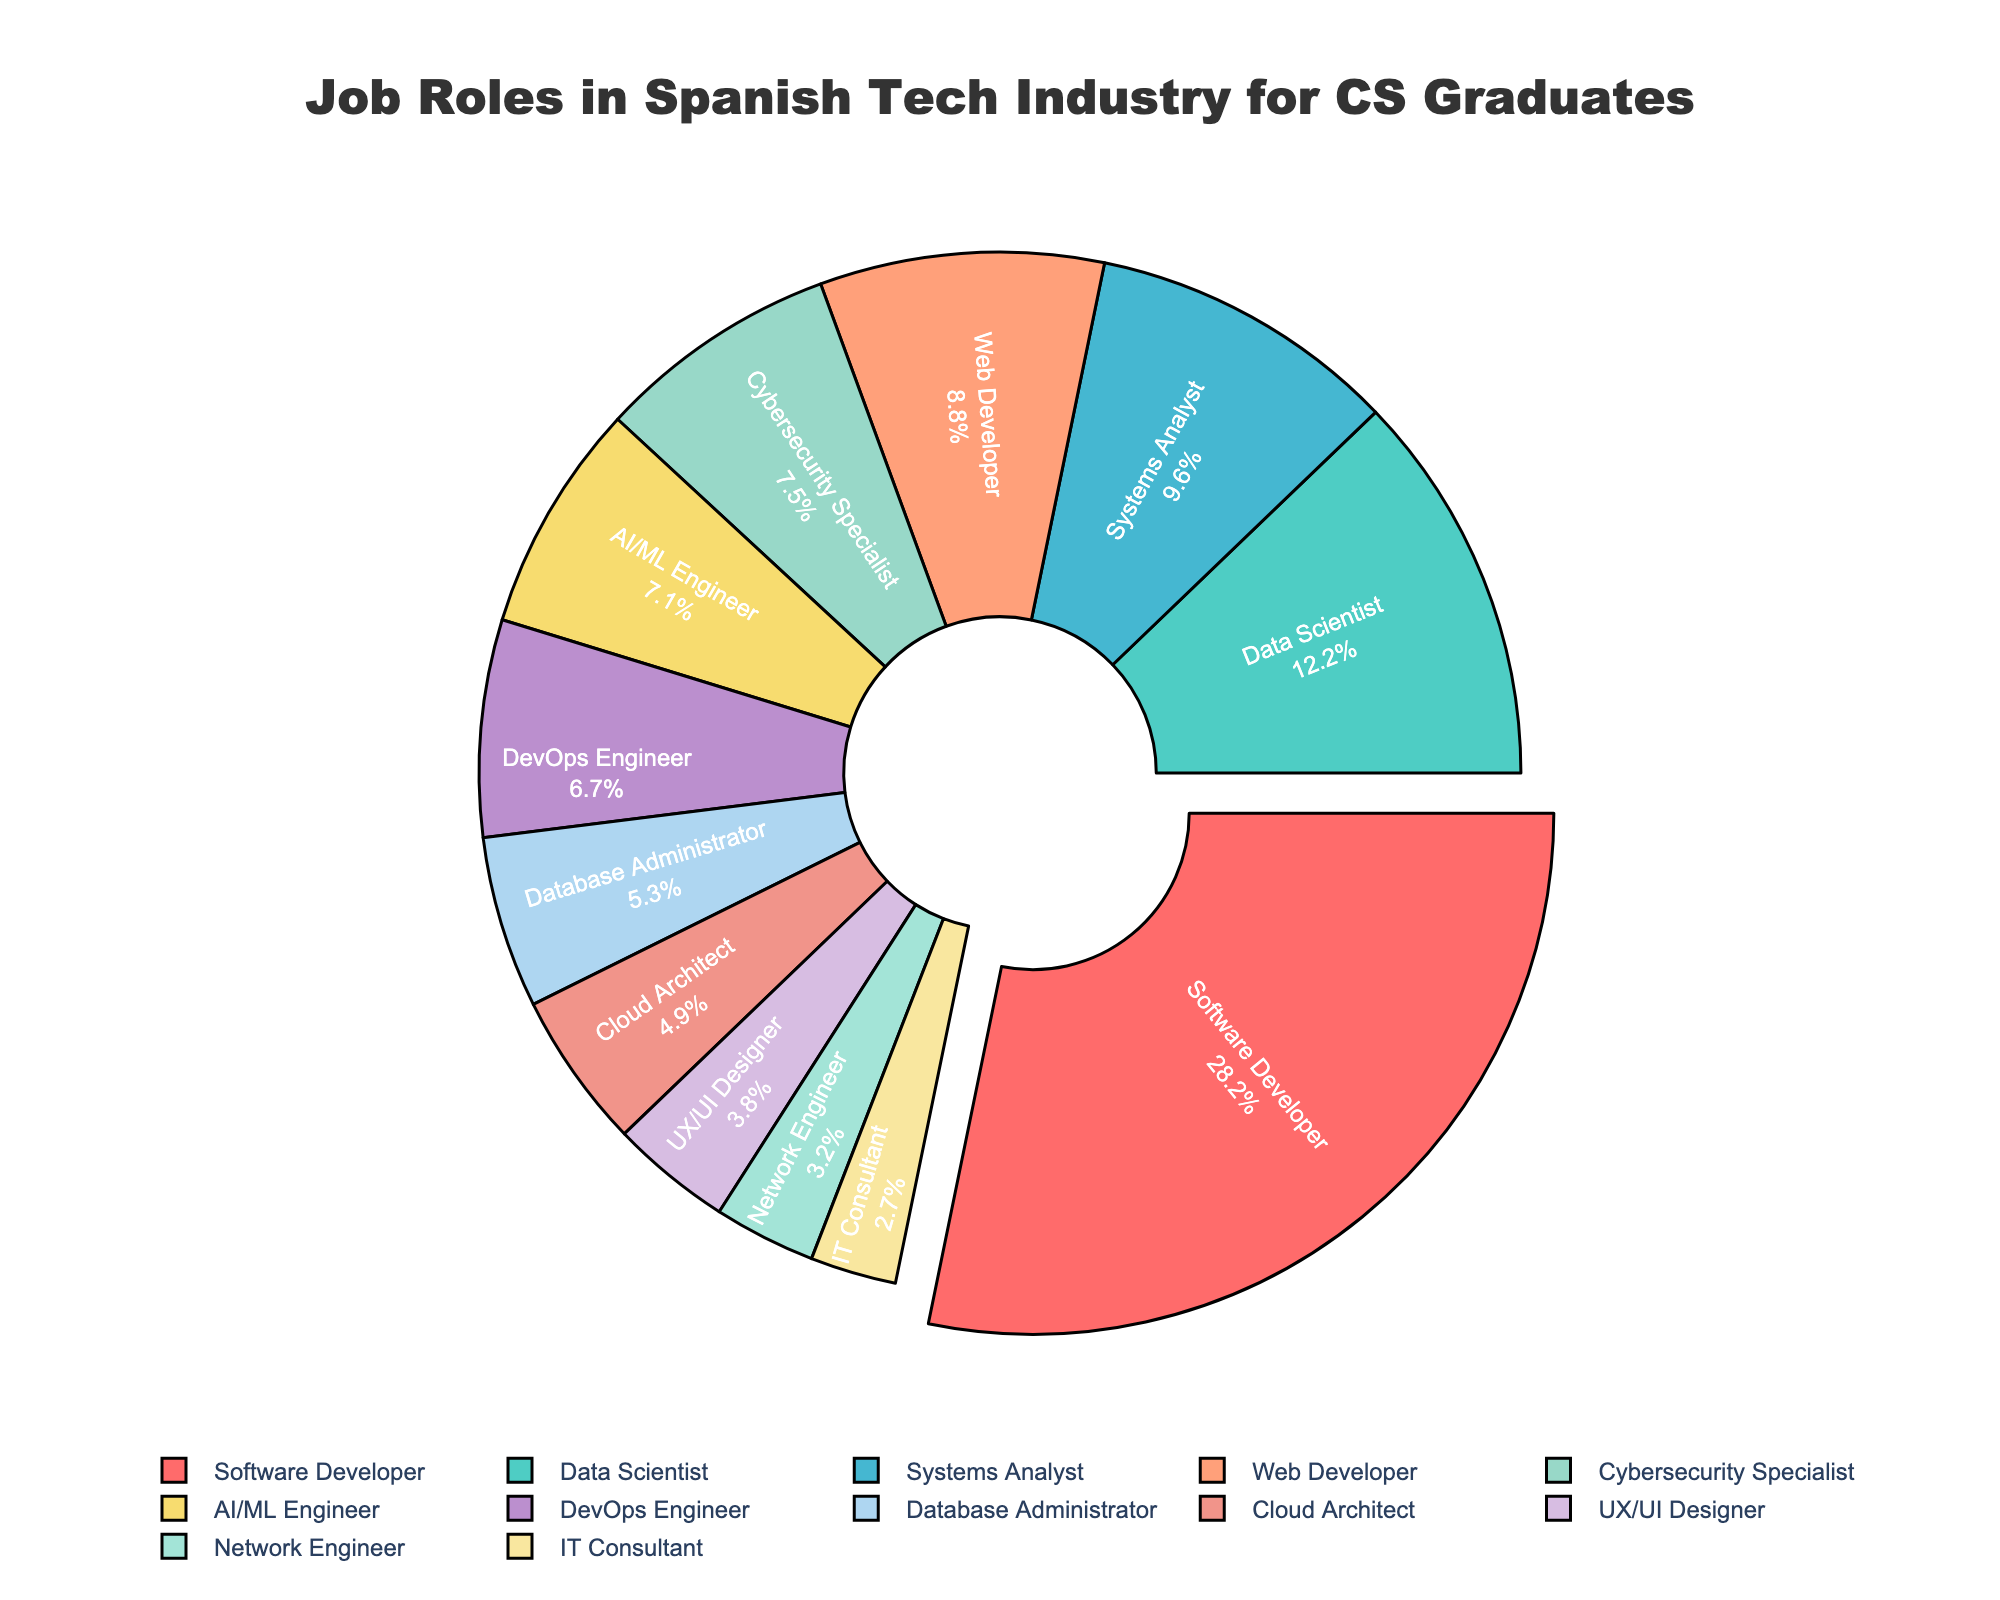What is the largest job role in the Spanish tech industry for CS graduates? The largest job role for CS graduates is the Software Developer. This is evident from the pie chart segment corresponding to Software Developer, occupying the largest share with 28.5%.
Answer: Software Developer What is the combined percentage of Data Scientists and AI/ML Engineers? To find the combined percentage of Data Scientists and AI/ML Engineers, sum their respective percentages (12.3% for Data Scientists and 7.2% for AI/ML Engineers). 12.3 + 7.2 = 19.5%.
Answer: 19.5% Which job role has a greater percentage, DevOps Engineer or Cloud Architect? From the pie chart, the percentage for DevOps Engineer is 6.8%, and for Cloud Architect, it is 4.9%. Comparing these two percentages, DevOps Engineer has a greater percentage.
Answer: DevOps Engineer How much larger is the percentage of Systems Analysts compared to IT Consultants? The percentage for Systems Analysts is 9.7%, and for IT Consultants, it is 2.7%. Subtracting these values, 9.7 - 2.7 = 7%. Hence, Systems Analysts have a 7% larger share.
Answer: 7% Can you list the job roles occupying less than 5% in the industry? The job roles occupying less than 5% are determined by looking at all segments that are less than 5%. These are Cloud Architect (4.9%), UX/UI Designer (3.8%), Network Engineer (3.2%), and IT Consultant (2.7%).
Answer: Cloud Architect, UX/UI Designer, Network Engineer, IT Consultant What is the total percentage of Cloud-related roles (Cloud Architect and DevOps Engineer)? To find the total percentage of Cloud-related roles, sum the percentages for Cloud Architect (4.9%) and DevOps Engineer (6.8%). 4.9 + 6.8 = 11.7%.
Answer: 11.7% Which color represents the Cybersecurity Specialist role in the chart? The color corresponding to the Cybersecurity Specialist segment in the pie chart can be identified as the specific color assigning to this label. In the code, it is given as a distinct color among others. The pie chart shows Cybersecurity Specialist in a purple shade.
Answer: purple shade Are there more Software Developers or Web Developers in the Spanish tech industry? From the pie chart, the percentage for Software Developers is 28.5%, while it is 8.9% for Web Developers. Comparing these values, we see that there are significantly more Software Developers than Web Developers.
Answer: Software Developers What is the difference in percentage between Network Engineers and Systems Analysts? The percentage for Systems Analysts is 9.7%, and for Network Engineers, it is 3.2%. Subtracting these values yields 9.7 - 3.2 = 6.5%.
Answer: 6.5% How does the percentage of UX/UI Designers compare to that of Database Administrators? The percentage for UX/UI Designers is 3.8%, and for Database Administrators, it is 5.4%. Comparing these values, UX/UI Designers have a smaller percentage.
Answer: UX/UI Designers have a smaller percentage 